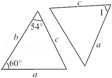What is the possible value of the angle at point B in triangle ABC, and how does it relate to triangle DEF? The angle at point B in triangle ABC can be calculated using the angle sum property of triangles, which is 180 degrees. Given angles 54 degrees and 60 degrees, angle B would be 66 degrees. Since both triangles are congruent as indicated by their labeling, DEF will have a corresponding angle at E also measuring 66 degrees. 